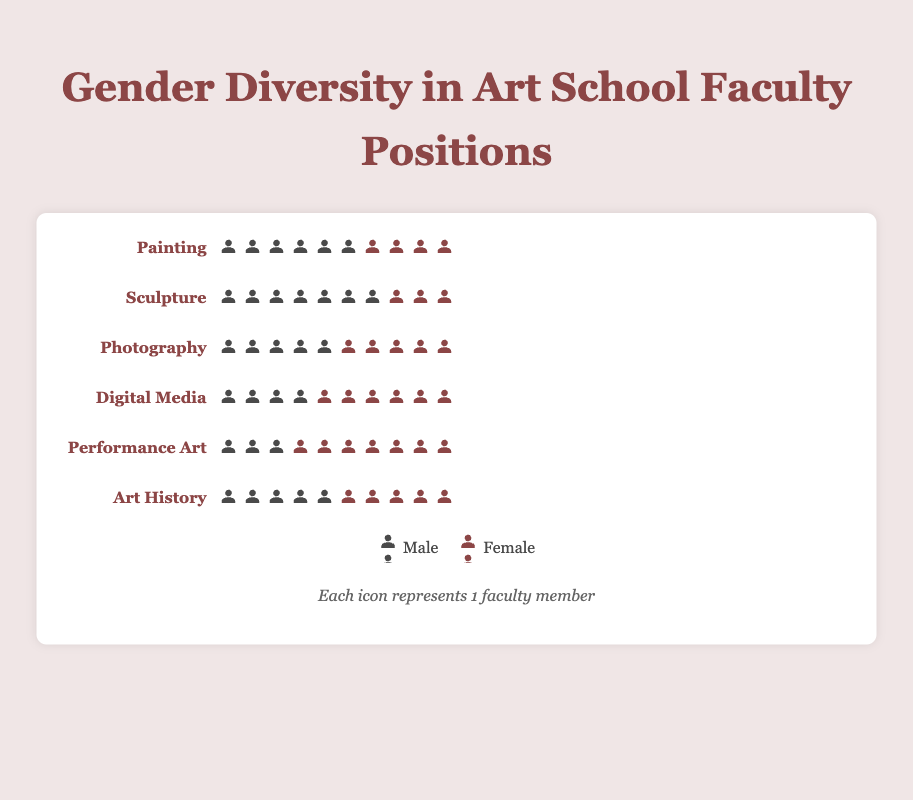What's the title of the figure? The title is located at the top of the figure and typically summarizes the main topic of the visualization.
Answer: Gender Diversity in Art School Faculty Positions Which discipline has the highest number of male faculty members? By looking at the number of male icons for each discipline, Sculpture has the highest with 7 male icons.
Answer: Sculpture How many total faculty members are represented in the Photography discipline? Adding the number of male and female icons in Photography, 5 male + 5 female = 10 total faculty members.
Answer: 10 In which discipline is there the greatest gender disparity among faculty members? Comparing the difference in the number of male and female icons in each discipline, Sculpture has the greatest disparity with a difference of 4 (7 males - 3 females).
Answer: Sculpture Which disciplines have an equal number of male and female faculty members? By identifying the disciplines with equal numbers of male and female icons, Photography and Art History both have 5 male and 5 female faculty members.
Answer: Photography and Art History What is the total number of male faculty members across all disciplines? Summing the number of male icons across all disciplines: 6 (Painting) + 7 (Sculpture) + 5 (Photography) + 4 (Digital Media) + 3 (Performance Art) + 5 (Art History) = 30 male faculty members.
Answer: 30 Which discipline has more female than male faculty members? Observing the disciplines and noting where female icons exceed male icons, Digital Media and Performance Art have more female faculty members.
Answer: Digital Media and Performance Art What is the total number of faculty members in Painting and Sculpture combined? Adding the total faculty members (male + female) in both disciplines: Painting (6 males + 4 females = 10) + Sculpture (7 males + 3 females = 10), so 10 + 10 = 20 faculty members.
Answer: 20 Which discipline has the highest number of female faculty members? By checking the number of female icons in each discipline, Performance Art has the highest with 7 female icons.
Answer: Performance Art What is the average number of female faculty members per discipline? Calculating the total number of female faculty members and dividing by the number of disciplines: (4 + 3 + 5 + 6 + 7 + 5) / 6 = 30 / 6 = 5 female faculty members per discipline.
Answer: 5 